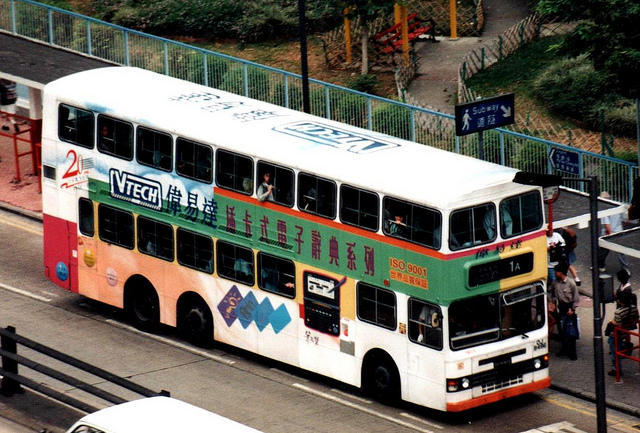Please extract the text content from this image. ISO 9001 1A 20 VTECH 